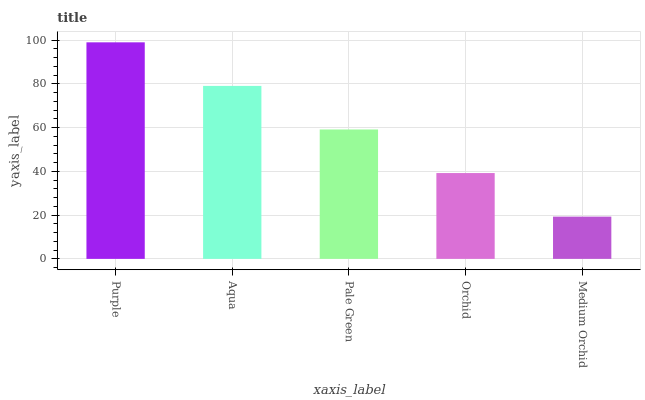Is Medium Orchid the minimum?
Answer yes or no. Yes. Is Purple the maximum?
Answer yes or no. Yes. Is Aqua the minimum?
Answer yes or no. No. Is Aqua the maximum?
Answer yes or no. No. Is Purple greater than Aqua?
Answer yes or no. Yes. Is Aqua less than Purple?
Answer yes or no. Yes. Is Aqua greater than Purple?
Answer yes or no. No. Is Purple less than Aqua?
Answer yes or no. No. Is Pale Green the high median?
Answer yes or no. Yes. Is Pale Green the low median?
Answer yes or no. Yes. Is Orchid the high median?
Answer yes or no. No. Is Purple the low median?
Answer yes or no. No. 